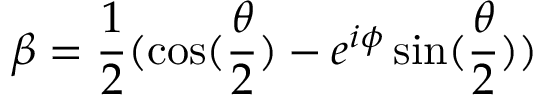Convert formula to latex. <formula><loc_0><loc_0><loc_500><loc_500>\beta = \frac { 1 } { 2 } ( \cos ( \frac { \theta } { 2 } ) - e ^ { i \phi } \sin ( \frac { \theta } { 2 } ) )</formula> 